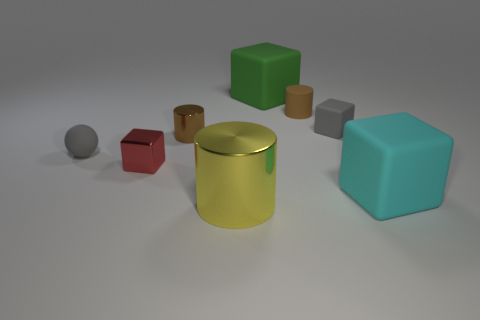There is a gray thing to the left of the brown shiny thing; is its size the same as the cylinder in front of the red metallic object?
Offer a very short reply. No. Is the material of the tiny block behind the tiny rubber ball the same as the red thing?
Offer a very short reply. No. What number of other objects are the same size as the yellow cylinder?
Offer a very short reply. 2. How many big things are either yellow rubber cubes or cyan cubes?
Your answer should be compact. 1. Do the rubber cylinder and the small metallic cylinder have the same color?
Your answer should be compact. Yes. Is the number of small red metallic blocks that are on the left side of the big cyan object greater than the number of small gray rubber objects to the right of the tiny gray rubber cube?
Provide a short and direct response. Yes. There is a rubber sphere in front of the tiny metal cylinder; does it have the same color as the small rubber block?
Make the answer very short. Yes. Is there any other thing that has the same color as the large metallic thing?
Your answer should be compact. No. Are there more shiny things to the left of the brown rubber cylinder than cyan matte objects?
Offer a very short reply. Yes. Is the size of the gray ball the same as the brown shiny cylinder?
Ensure brevity in your answer.  Yes. 